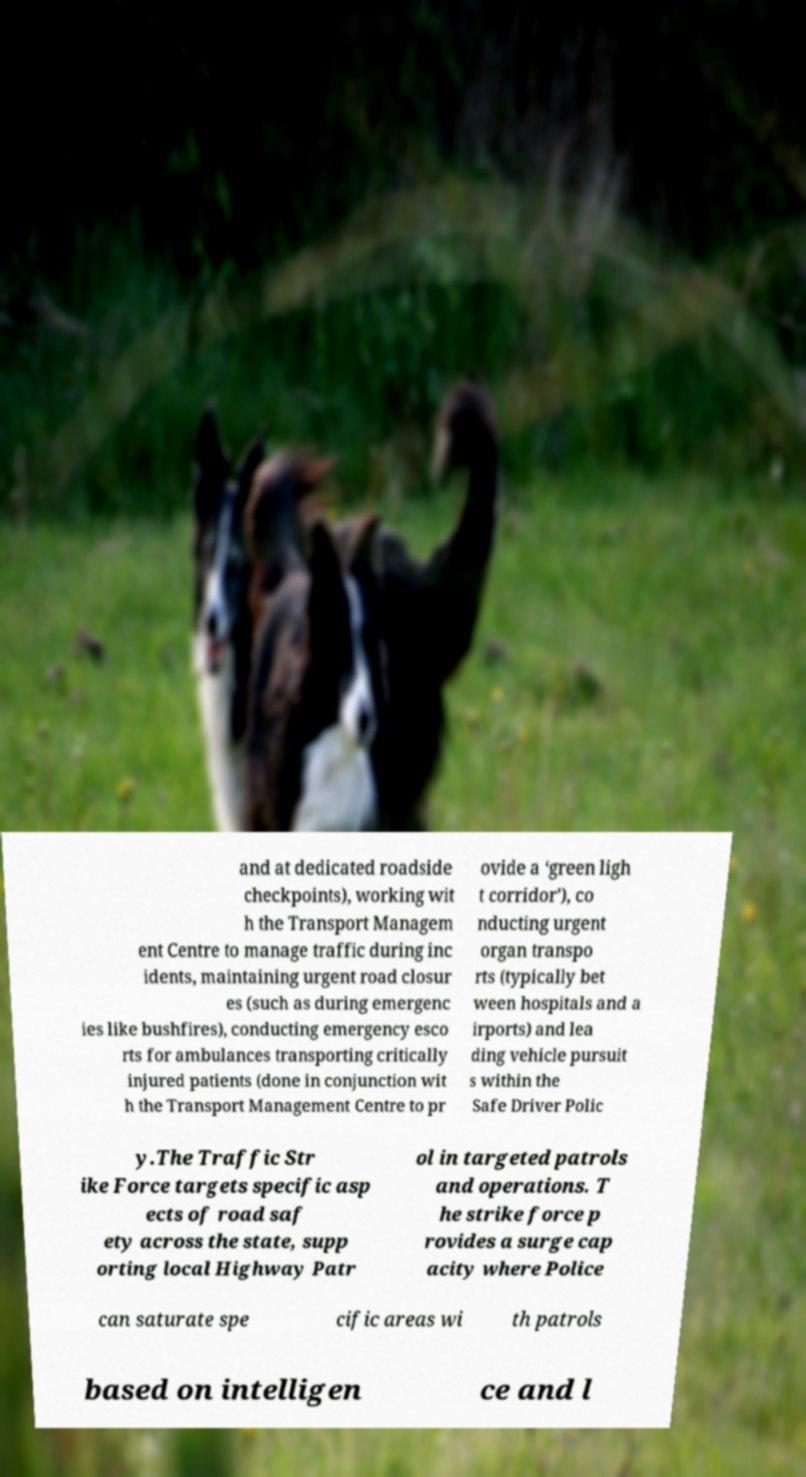Please identify and transcribe the text found in this image. and at dedicated roadside checkpoints), working wit h the Transport Managem ent Centre to manage traffic during inc idents, maintaining urgent road closur es (such as during emergenc ies like bushfires), conducting emergency esco rts for ambulances transporting critically injured patients (done in conjunction wit h the Transport Management Centre to pr ovide a ‘green ligh t corridor’), co nducting urgent organ transpo rts (typically bet ween hospitals and a irports) and lea ding vehicle pursuit s within the Safe Driver Polic y.The Traffic Str ike Force targets specific asp ects of road saf ety across the state, supp orting local Highway Patr ol in targeted patrols and operations. T he strike force p rovides a surge cap acity where Police can saturate spe cific areas wi th patrols based on intelligen ce and l 